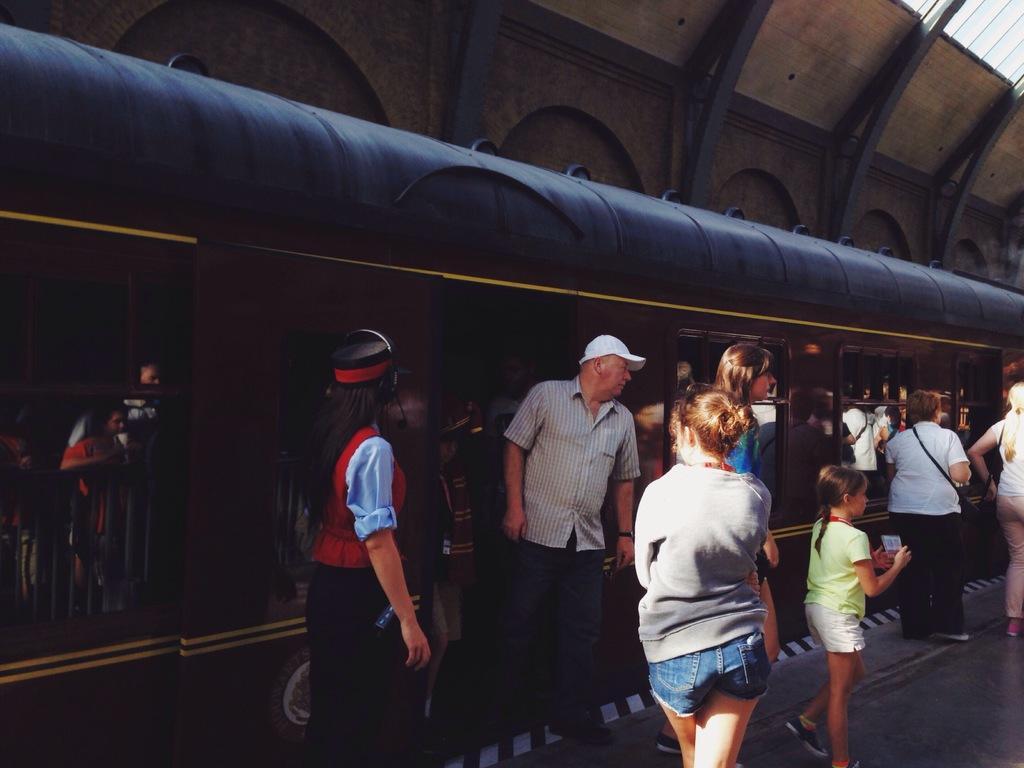Could you give a brief overview of what you see in this image? In this image there is a train in the middle. At the top there is a roof. At the bottom there are few people standing on the platform. 